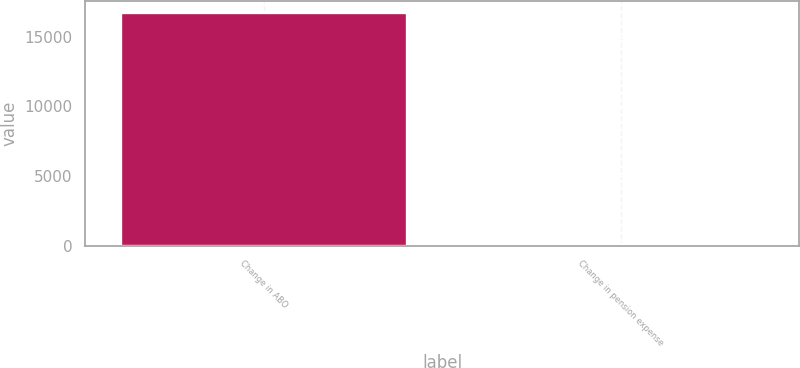Convert chart. <chart><loc_0><loc_0><loc_500><loc_500><bar_chart><fcel>Change in ABO<fcel>Change in pension expense<nl><fcel>16698<fcel>148<nl></chart> 